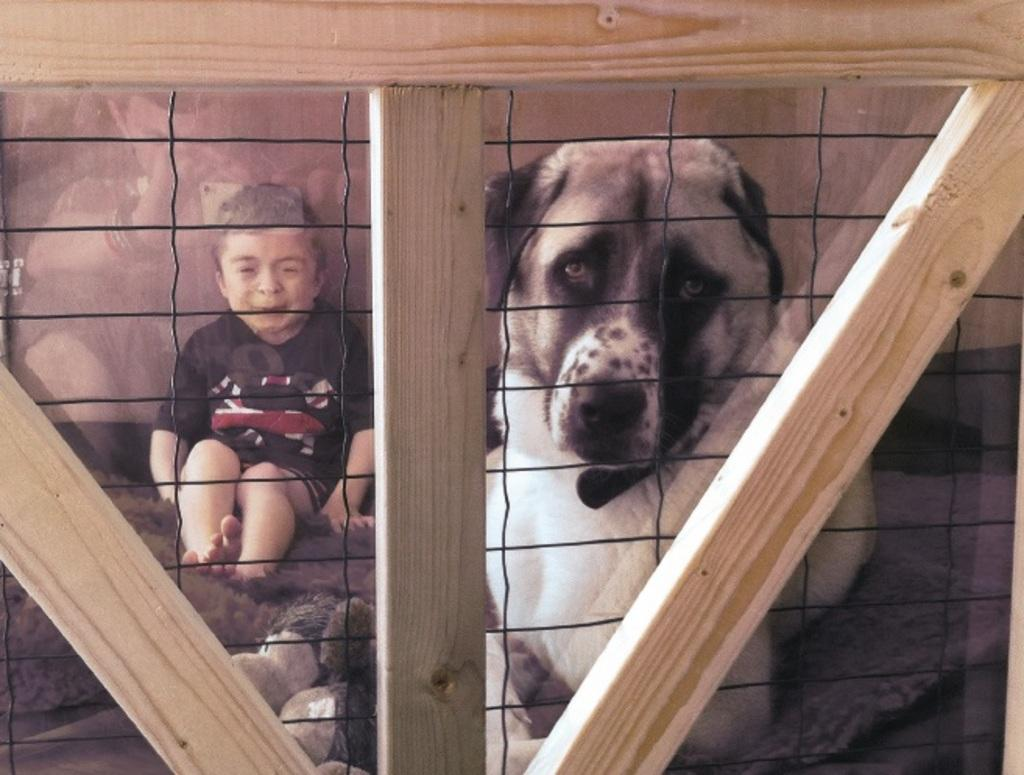Who or what can be seen sitting on the floor in the picture? There is a boy and a dog sitting on the floor in the picture. What is the boy's relationship to the dog in the image? The provided facts do not specify the relationship between the boy and the dog. What type of structure is visible in the picture? There is a wooden frame in the picture. What type of barrier can be seen in the image? There is a fence in the picture. What type of soda is the boy drinking in the picture? There is no soda present in the image; the boy and the dog are sitting on the floor. Can you see any quince trees in the picture? There is no mention of quince trees or any trees in the provided facts, so it cannot be determined if they are present in the image. 